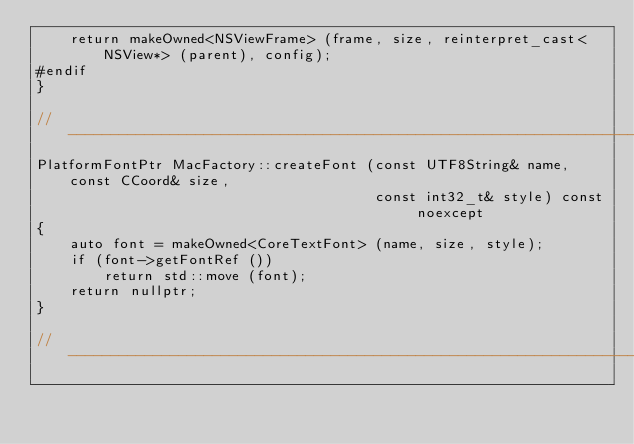Convert code to text. <code><loc_0><loc_0><loc_500><loc_500><_ObjectiveC_>	return makeOwned<NSViewFrame> (frame, size, reinterpret_cast<NSView*> (parent), config);
#endif
}

//-----------------------------------------------------------------------------
PlatformFontPtr MacFactory::createFont (const UTF8String& name, const CCoord& size,
										const int32_t& style) const noexcept
{
	auto font = makeOwned<CoreTextFont> (name, size, style);
	if (font->getFontRef ())
		return std::move (font);
	return nullptr;
}

//-----------------------------------------------------------------------------</code> 